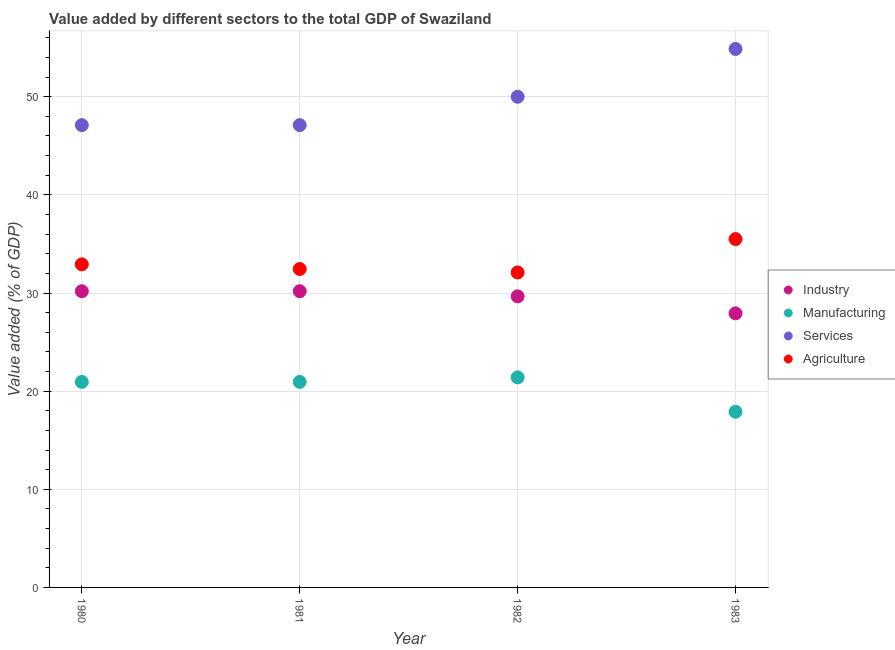How many different coloured dotlines are there?
Your answer should be very brief. 4. What is the value added by manufacturing sector in 1982?
Your response must be concise. 21.4. Across all years, what is the maximum value added by manufacturing sector?
Give a very brief answer. 21.4. Across all years, what is the minimum value added by industrial sector?
Keep it short and to the point. 27.93. What is the total value added by manufacturing sector in the graph?
Offer a terse response. 81.19. What is the difference between the value added by agricultural sector in 1981 and that in 1982?
Your answer should be compact. 0.35. What is the difference between the value added by agricultural sector in 1982 and the value added by services sector in 1981?
Ensure brevity in your answer.  -15.02. What is the average value added by manufacturing sector per year?
Provide a short and direct response. 20.3. In the year 1983, what is the difference between the value added by agricultural sector and value added by services sector?
Your answer should be very brief. -19.37. In how many years, is the value added by agricultural sector greater than 24 %?
Provide a succinct answer. 4. What is the ratio of the value added by services sector in 1980 to that in 1982?
Provide a succinct answer. 0.94. What is the difference between the highest and the second highest value added by manufacturing sector?
Provide a short and direct response. 0.46. What is the difference between the highest and the lowest value added by manufacturing sector?
Ensure brevity in your answer.  3.5. Is the sum of the value added by services sector in 1981 and 1982 greater than the maximum value added by agricultural sector across all years?
Give a very brief answer. Yes. Does the value added by manufacturing sector monotonically increase over the years?
Your answer should be very brief. No. Is the value added by services sector strictly less than the value added by agricultural sector over the years?
Make the answer very short. No. What is the difference between two consecutive major ticks on the Y-axis?
Keep it short and to the point. 10. Does the graph contain any zero values?
Your answer should be very brief. No. Where does the legend appear in the graph?
Offer a very short reply. Center right. How many legend labels are there?
Ensure brevity in your answer.  4. How are the legend labels stacked?
Offer a very short reply. Vertical. What is the title of the graph?
Give a very brief answer. Value added by different sectors to the total GDP of Swaziland. Does "Secondary general" appear as one of the legend labels in the graph?
Ensure brevity in your answer.  No. What is the label or title of the X-axis?
Your answer should be compact. Year. What is the label or title of the Y-axis?
Offer a terse response. Value added (% of GDP). What is the Value added (% of GDP) of Industry in 1980?
Provide a short and direct response. 30.18. What is the Value added (% of GDP) of Manufacturing in 1980?
Make the answer very short. 20.94. What is the Value added (% of GDP) of Services in 1980?
Your answer should be compact. 47.11. What is the Value added (% of GDP) of Agriculture in 1980?
Offer a very short reply. 32.92. What is the Value added (% of GDP) in Industry in 1981?
Give a very brief answer. 30.18. What is the Value added (% of GDP) of Manufacturing in 1981?
Give a very brief answer. 20.94. What is the Value added (% of GDP) in Services in 1981?
Your answer should be very brief. 47.11. What is the Value added (% of GDP) of Agriculture in 1981?
Ensure brevity in your answer.  32.45. What is the Value added (% of GDP) of Industry in 1982?
Offer a terse response. 29.66. What is the Value added (% of GDP) of Manufacturing in 1982?
Provide a succinct answer. 21.4. What is the Value added (% of GDP) in Agriculture in 1982?
Make the answer very short. 32.09. What is the Value added (% of GDP) of Industry in 1983?
Your response must be concise. 27.93. What is the Value added (% of GDP) of Manufacturing in 1983?
Offer a very short reply. 17.9. What is the Value added (% of GDP) in Services in 1983?
Provide a succinct answer. 54.87. What is the Value added (% of GDP) of Agriculture in 1983?
Keep it short and to the point. 35.5. Across all years, what is the maximum Value added (% of GDP) of Industry?
Your answer should be compact. 30.18. Across all years, what is the maximum Value added (% of GDP) in Manufacturing?
Offer a very short reply. 21.4. Across all years, what is the maximum Value added (% of GDP) in Services?
Your response must be concise. 54.87. Across all years, what is the maximum Value added (% of GDP) of Agriculture?
Offer a very short reply. 35.5. Across all years, what is the minimum Value added (% of GDP) in Industry?
Make the answer very short. 27.93. Across all years, what is the minimum Value added (% of GDP) in Manufacturing?
Ensure brevity in your answer.  17.9. Across all years, what is the minimum Value added (% of GDP) of Services?
Make the answer very short. 47.11. Across all years, what is the minimum Value added (% of GDP) in Agriculture?
Ensure brevity in your answer.  32.09. What is the total Value added (% of GDP) of Industry in the graph?
Keep it short and to the point. 117.96. What is the total Value added (% of GDP) in Manufacturing in the graph?
Your response must be concise. 81.19. What is the total Value added (% of GDP) of Services in the graph?
Make the answer very short. 199.09. What is the total Value added (% of GDP) of Agriculture in the graph?
Your answer should be very brief. 132.96. What is the difference between the Value added (% of GDP) in Manufacturing in 1980 and that in 1981?
Give a very brief answer. -0. What is the difference between the Value added (% of GDP) of Agriculture in 1980 and that in 1981?
Offer a very short reply. 0.47. What is the difference between the Value added (% of GDP) in Industry in 1980 and that in 1982?
Give a very brief answer. 0.52. What is the difference between the Value added (% of GDP) in Manufacturing in 1980 and that in 1982?
Your answer should be very brief. -0.46. What is the difference between the Value added (% of GDP) of Services in 1980 and that in 1982?
Ensure brevity in your answer.  -2.89. What is the difference between the Value added (% of GDP) in Agriculture in 1980 and that in 1982?
Provide a succinct answer. 0.83. What is the difference between the Value added (% of GDP) in Industry in 1980 and that in 1983?
Provide a succinct answer. 2.25. What is the difference between the Value added (% of GDP) in Manufacturing in 1980 and that in 1983?
Your answer should be very brief. 3.05. What is the difference between the Value added (% of GDP) in Services in 1980 and that in 1983?
Keep it short and to the point. -7.76. What is the difference between the Value added (% of GDP) of Agriculture in 1980 and that in 1983?
Your answer should be compact. -2.58. What is the difference between the Value added (% of GDP) in Industry in 1981 and that in 1982?
Provide a succinct answer. 0.52. What is the difference between the Value added (% of GDP) in Manufacturing in 1981 and that in 1982?
Give a very brief answer. -0.46. What is the difference between the Value added (% of GDP) of Services in 1981 and that in 1982?
Your answer should be very brief. -2.89. What is the difference between the Value added (% of GDP) in Agriculture in 1981 and that in 1982?
Keep it short and to the point. 0.35. What is the difference between the Value added (% of GDP) in Industry in 1981 and that in 1983?
Your response must be concise. 2.25. What is the difference between the Value added (% of GDP) in Manufacturing in 1981 and that in 1983?
Provide a short and direct response. 3.05. What is the difference between the Value added (% of GDP) of Services in 1981 and that in 1983?
Keep it short and to the point. -7.76. What is the difference between the Value added (% of GDP) of Agriculture in 1981 and that in 1983?
Your response must be concise. -3.05. What is the difference between the Value added (% of GDP) of Industry in 1982 and that in 1983?
Offer a terse response. 1.73. What is the difference between the Value added (% of GDP) in Manufacturing in 1982 and that in 1983?
Provide a succinct answer. 3.5. What is the difference between the Value added (% of GDP) of Services in 1982 and that in 1983?
Ensure brevity in your answer.  -4.87. What is the difference between the Value added (% of GDP) of Agriculture in 1982 and that in 1983?
Offer a very short reply. -3.4. What is the difference between the Value added (% of GDP) of Industry in 1980 and the Value added (% of GDP) of Manufacturing in 1981?
Give a very brief answer. 9.24. What is the difference between the Value added (% of GDP) in Industry in 1980 and the Value added (% of GDP) in Services in 1981?
Provide a succinct answer. -16.93. What is the difference between the Value added (% of GDP) of Industry in 1980 and the Value added (% of GDP) of Agriculture in 1981?
Make the answer very short. -2.26. What is the difference between the Value added (% of GDP) in Manufacturing in 1980 and the Value added (% of GDP) in Services in 1981?
Offer a terse response. -26.16. What is the difference between the Value added (% of GDP) of Manufacturing in 1980 and the Value added (% of GDP) of Agriculture in 1981?
Provide a short and direct response. -11.5. What is the difference between the Value added (% of GDP) of Services in 1980 and the Value added (% of GDP) of Agriculture in 1981?
Your response must be concise. 14.66. What is the difference between the Value added (% of GDP) in Industry in 1980 and the Value added (% of GDP) in Manufacturing in 1982?
Keep it short and to the point. 8.78. What is the difference between the Value added (% of GDP) in Industry in 1980 and the Value added (% of GDP) in Services in 1982?
Your answer should be very brief. -19.82. What is the difference between the Value added (% of GDP) of Industry in 1980 and the Value added (% of GDP) of Agriculture in 1982?
Your response must be concise. -1.91. What is the difference between the Value added (% of GDP) in Manufacturing in 1980 and the Value added (% of GDP) in Services in 1982?
Your response must be concise. -29.05. What is the difference between the Value added (% of GDP) in Manufacturing in 1980 and the Value added (% of GDP) in Agriculture in 1982?
Your answer should be very brief. -11.15. What is the difference between the Value added (% of GDP) of Services in 1980 and the Value added (% of GDP) of Agriculture in 1982?
Make the answer very short. 15.02. What is the difference between the Value added (% of GDP) in Industry in 1980 and the Value added (% of GDP) in Manufacturing in 1983?
Provide a succinct answer. 12.29. What is the difference between the Value added (% of GDP) of Industry in 1980 and the Value added (% of GDP) of Services in 1983?
Make the answer very short. -24.68. What is the difference between the Value added (% of GDP) in Industry in 1980 and the Value added (% of GDP) in Agriculture in 1983?
Make the answer very short. -5.31. What is the difference between the Value added (% of GDP) in Manufacturing in 1980 and the Value added (% of GDP) in Services in 1983?
Make the answer very short. -33.92. What is the difference between the Value added (% of GDP) in Manufacturing in 1980 and the Value added (% of GDP) in Agriculture in 1983?
Ensure brevity in your answer.  -14.55. What is the difference between the Value added (% of GDP) in Services in 1980 and the Value added (% of GDP) in Agriculture in 1983?
Offer a terse response. 11.61. What is the difference between the Value added (% of GDP) in Industry in 1981 and the Value added (% of GDP) in Manufacturing in 1982?
Your answer should be very brief. 8.78. What is the difference between the Value added (% of GDP) in Industry in 1981 and the Value added (% of GDP) in Services in 1982?
Ensure brevity in your answer.  -19.82. What is the difference between the Value added (% of GDP) of Industry in 1981 and the Value added (% of GDP) of Agriculture in 1982?
Provide a short and direct response. -1.91. What is the difference between the Value added (% of GDP) of Manufacturing in 1981 and the Value added (% of GDP) of Services in 1982?
Your answer should be compact. -29.05. What is the difference between the Value added (% of GDP) of Manufacturing in 1981 and the Value added (% of GDP) of Agriculture in 1982?
Give a very brief answer. -11.15. What is the difference between the Value added (% of GDP) in Services in 1981 and the Value added (% of GDP) in Agriculture in 1982?
Offer a terse response. 15.02. What is the difference between the Value added (% of GDP) in Industry in 1981 and the Value added (% of GDP) in Manufacturing in 1983?
Make the answer very short. 12.29. What is the difference between the Value added (% of GDP) of Industry in 1981 and the Value added (% of GDP) of Services in 1983?
Ensure brevity in your answer.  -24.68. What is the difference between the Value added (% of GDP) of Industry in 1981 and the Value added (% of GDP) of Agriculture in 1983?
Offer a terse response. -5.31. What is the difference between the Value added (% of GDP) of Manufacturing in 1981 and the Value added (% of GDP) of Services in 1983?
Your response must be concise. -33.92. What is the difference between the Value added (% of GDP) in Manufacturing in 1981 and the Value added (% of GDP) in Agriculture in 1983?
Offer a very short reply. -14.55. What is the difference between the Value added (% of GDP) in Services in 1981 and the Value added (% of GDP) in Agriculture in 1983?
Your response must be concise. 11.61. What is the difference between the Value added (% of GDP) in Industry in 1982 and the Value added (% of GDP) in Manufacturing in 1983?
Provide a short and direct response. 11.76. What is the difference between the Value added (% of GDP) of Industry in 1982 and the Value added (% of GDP) of Services in 1983?
Offer a very short reply. -25.21. What is the difference between the Value added (% of GDP) of Industry in 1982 and the Value added (% of GDP) of Agriculture in 1983?
Provide a short and direct response. -5.84. What is the difference between the Value added (% of GDP) of Manufacturing in 1982 and the Value added (% of GDP) of Services in 1983?
Give a very brief answer. -33.47. What is the difference between the Value added (% of GDP) in Manufacturing in 1982 and the Value added (% of GDP) in Agriculture in 1983?
Provide a short and direct response. -14.09. What is the difference between the Value added (% of GDP) of Services in 1982 and the Value added (% of GDP) of Agriculture in 1983?
Your answer should be compact. 14.5. What is the average Value added (% of GDP) in Industry per year?
Provide a short and direct response. 29.49. What is the average Value added (% of GDP) of Manufacturing per year?
Make the answer very short. 20.3. What is the average Value added (% of GDP) in Services per year?
Your response must be concise. 49.77. What is the average Value added (% of GDP) of Agriculture per year?
Make the answer very short. 33.24. In the year 1980, what is the difference between the Value added (% of GDP) of Industry and Value added (% of GDP) of Manufacturing?
Ensure brevity in your answer.  9.24. In the year 1980, what is the difference between the Value added (% of GDP) in Industry and Value added (% of GDP) in Services?
Provide a succinct answer. -16.93. In the year 1980, what is the difference between the Value added (% of GDP) of Industry and Value added (% of GDP) of Agriculture?
Make the answer very short. -2.74. In the year 1980, what is the difference between the Value added (% of GDP) in Manufacturing and Value added (% of GDP) in Services?
Offer a terse response. -26.16. In the year 1980, what is the difference between the Value added (% of GDP) in Manufacturing and Value added (% of GDP) in Agriculture?
Make the answer very short. -11.97. In the year 1980, what is the difference between the Value added (% of GDP) in Services and Value added (% of GDP) in Agriculture?
Offer a very short reply. 14.19. In the year 1981, what is the difference between the Value added (% of GDP) of Industry and Value added (% of GDP) of Manufacturing?
Provide a succinct answer. 9.24. In the year 1981, what is the difference between the Value added (% of GDP) in Industry and Value added (% of GDP) in Services?
Your answer should be compact. -16.93. In the year 1981, what is the difference between the Value added (% of GDP) of Industry and Value added (% of GDP) of Agriculture?
Keep it short and to the point. -2.26. In the year 1981, what is the difference between the Value added (% of GDP) of Manufacturing and Value added (% of GDP) of Services?
Provide a succinct answer. -26.16. In the year 1981, what is the difference between the Value added (% of GDP) of Manufacturing and Value added (% of GDP) of Agriculture?
Give a very brief answer. -11.5. In the year 1981, what is the difference between the Value added (% of GDP) in Services and Value added (% of GDP) in Agriculture?
Your answer should be compact. 14.66. In the year 1982, what is the difference between the Value added (% of GDP) in Industry and Value added (% of GDP) in Manufacturing?
Your answer should be compact. 8.26. In the year 1982, what is the difference between the Value added (% of GDP) of Industry and Value added (% of GDP) of Services?
Keep it short and to the point. -20.34. In the year 1982, what is the difference between the Value added (% of GDP) of Industry and Value added (% of GDP) of Agriculture?
Your response must be concise. -2.43. In the year 1982, what is the difference between the Value added (% of GDP) of Manufacturing and Value added (% of GDP) of Services?
Keep it short and to the point. -28.6. In the year 1982, what is the difference between the Value added (% of GDP) in Manufacturing and Value added (% of GDP) in Agriculture?
Make the answer very short. -10.69. In the year 1982, what is the difference between the Value added (% of GDP) of Services and Value added (% of GDP) of Agriculture?
Make the answer very short. 17.91. In the year 1983, what is the difference between the Value added (% of GDP) of Industry and Value added (% of GDP) of Manufacturing?
Provide a short and direct response. 10.04. In the year 1983, what is the difference between the Value added (% of GDP) in Industry and Value added (% of GDP) in Services?
Your answer should be very brief. -26.94. In the year 1983, what is the difference between the Value added (% of GDP) of Industry and Value added (% of GDP) of Agriculture?
Your response must be concise. -7.56. In the year 1983, what is the difference between the Value added (% of GDP) in Manufacturing and Value added (% of GDP) in Services?
Provide a short and direct response. -36.97. In the year 1983, what is the difference between the Value added (% of GDP) in Manufacturing and Value added (% of GDP) in Agriculture?
Your answer should be compact. -17.6. In the year 1983, what is the difference between the Value added (% of GDP) in Services and Value added (% of GDP) in Agriculture?
Provide a succinct answer. 19.37. What is the ratio of the Value added (% of GDP) of Industry in 1980 to that in 1981?
Your answer should be compact. 1. What is the ratio of the Value added (% of GDP) in Manufacturing in 1980 to that in 1981?
Ensure brevity in your answer.  1. What is the ratio of the Value added (% of GDP) in Services in 1980 to that in 1981?
Ensure brevity in your answer.  1. What is the ratio of the Value added (% of GDP) in Agriculture in 1980 to that in 1981?
Provide a short and direct response. 1.01. What is the ratio of the Value added (% of GDP) of Industry in 1980 to that in 1982?
Offer a very short reply. 1.02. What is the ratio of the Value added (% of GDP) of Manufacturing in 1980 to that in 1982?
Offer a very short reply. 0.98. What is the ratio of the Value added (% of GDP) of Services in 1980 to that in 1982?
Offer a terse response. 0.94. What is the ratio of the Value added (% of GDP) in Agriculture in 1980 to that in 1982?
Offer a terse response. 1.03. What is the ratio of the Value added (% of GDP) of Industry in 1980 to that in 1983?
Ensure brevity in your answer.  1.08. What is the ratio of the Value added (% of GDP) in Manufacturing in 1980 to that in 1983?
Your answer should be very brief. 1.17. What is the ratio of the Value added (% of GDP) in Services in 1980 to that in 1983?
Provide a succinct answer. 0.86. What is the ratio of the Value added (% of GDP) in Agriculture in 1980 to that in 1983?
Your answer should be compact. 0.93. What is the ratio of the Value added (% of GDP) of Industry in 1981 to that in 1982?
Provide a succinct answer. 1.02. What is the ratio of the Value added (% of GDP) of Manufacturing in 1981 to that in 1982?
Your response must be concise. 0.98. What is the ratio of the Value added (% of GDP) of Services in 1981 to that in 1982?
Make the answer very short. 0.94. What is the ratio of the Value added (% of GDP) in Agriculture in 1981 to that in 1982?
Offer a very short reply. 1.01. What is the ratio of the Value added (% of GDP) of Industry in 1981 to that in 1983?
Make the answer very short. 1.08. What is the ratio of the Value added (% of GDP) in Manufacturing in 1981 to that in 1983?
Offer a terse response. 1.17. What is the ratio of the Value added (% of GDP) in Services in 1981 to that in 1983?
Offer a terse response. 0.86. What is the ratio of the Value added (% of GDP) of Agriculture in 1981 to that in 1983?
Provide a short and direct response. 0.91. What is the ratio of the Value added (% of GDP) in Industry in 1982 to that in 1983?
Your answer should be compact. 1.06. What is the ratio of the Value added (% of GDP) of Manufacturing in 1982 to that in 1983?
Keep it short and to the point. 1.2. What is the ratio of the Value added (% of GDP) of Services in 1982 to that in 1983?
Make the answer very short. 0.91. What is the ratio of the Value added (% of GDP) in Agriculture in 1982 to that in 1983?
Make the answer very short. 0.9. What is the difference between the highest and the second highest Value added (% of GDP) in Manufacturing?
Keep it short and to the point. 0.46. What is the difference between the highest and the second highest Value added (% of GDP) in Services?
Provide a short and direct response. 4.87. What is the difference between the highest and the second highest Value added (% of GDP) of Agriculture?
Ensure brevity in your answer.  2.58. What is the difference between the highest and the lowest Value added (% of GDP) of Industry?
Make the answer very short. 2.25. What is the difference between the highest and the lowest Value added (% of GDP) in Manufacturing?
Ensure brevity in your answer.  3.5. What is the difference between the highest and the lowest Value added (% of GDP) in Services?
Your response must be concise. 7.76. What is the difference between the highest and the lowest Value added (% of GDP) of Agriculture?
Make the answer very short. 3.4. 